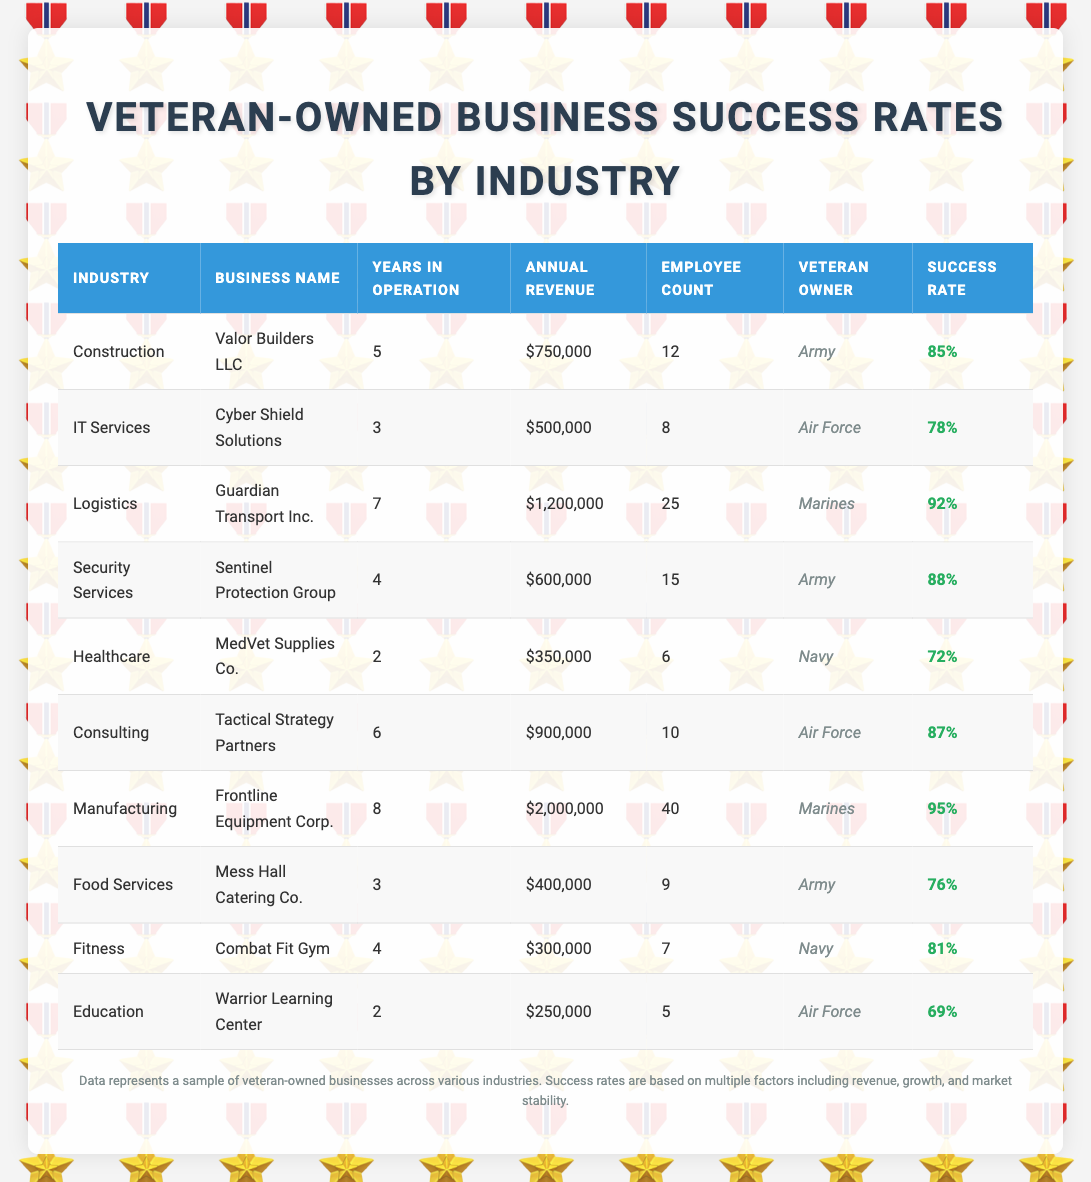What is the success rate of the business in the Logistics industry? The Logistics industry has the business "Guardian Transport Inc.", which has a success rate listed as 92%.
Answer: 92% Which veteran owner has the highest success rate? The business "Frontline Equipment Corp." owned by a Marine has the highest success rate of 95%.
Answer: Marine What is the total annual revenue of all businesses in the Construction industry? The only business in the Construction industry is "Valor Builders LLC," which has an annual revenue of $750,000. Therefore, the total annual revenue for Construction is $750,000.
Answer: $750,000 Is there a Healthcare business with a success rate higher than 75%? "MedVet Supplies Co." is the only Healthcare business, and its success rate is 72%, which is below 75%. Therefore, the answer is no.
Answer: No What is the average success rate of businesses owned by Army veterans? The Army veterans own "Valor Builders LLC" (85%), "Sentinel Protection Group" (88%), and "Mess Hall Catering Co." (76%). To find the average, we sum these rates: 85 + 88 + 76 = 249, then divide by 3, giving an average success rate of 83%.
Answer: 83% How many businesses have a success rate of 80% or higher? The businesses with success rates of 80% or higher are "Valor Builders LLC" (85%), "Guardian Transport Inc." (92%), "Sentinel Protection Group" (88%), "Tactical Strategy Partners" (87%), "Frontline Equipment Corp." (95%), and "Combat Fit Gym" (81%), totaling 6 businesses.
Answer: 6 Which industry has the lowest success rate and what is that rate? The industry with the lowest success rate is Education, represented by "Warrior Learning Center," which has a success rate of 69%.
Answer: 69% How many years, on average, have the businesses in the IT Services industry been in operation? The IT Services industry has one business, "Cyber Shield Solutions," which has been in operation for 3 years. Thus, the average is also 3 years.
Answer: 3 years Is there a business that has been in operation for more than 6 years? Yes, "Guardian Transport Inc." has been in operation for 7 years and "Frontline Equipment Corp." has been in operation for 8 years, confirming that there are businesses with more than 6 years of operation.
Answer: Yes 